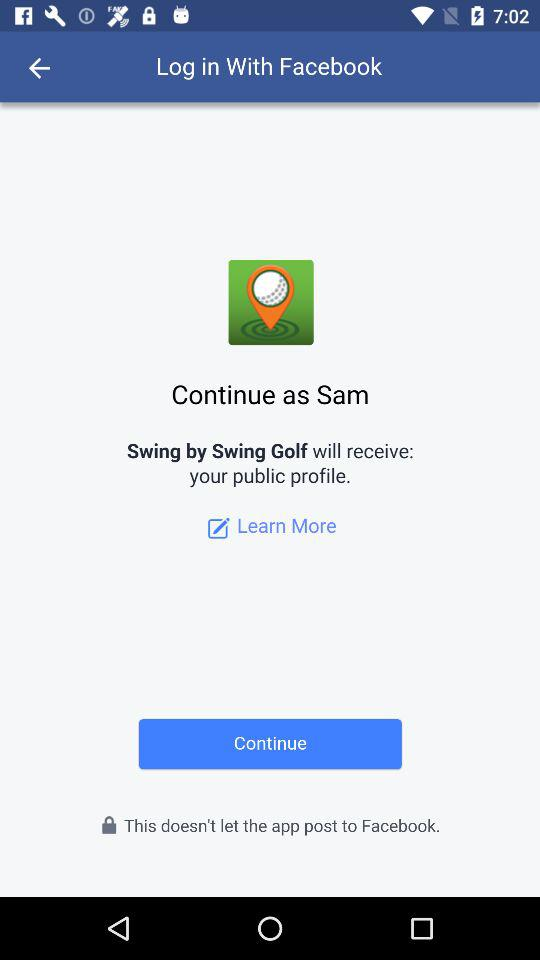What application is asking for permission? The application that is asking for permission is "Swing by Swing Golf". 